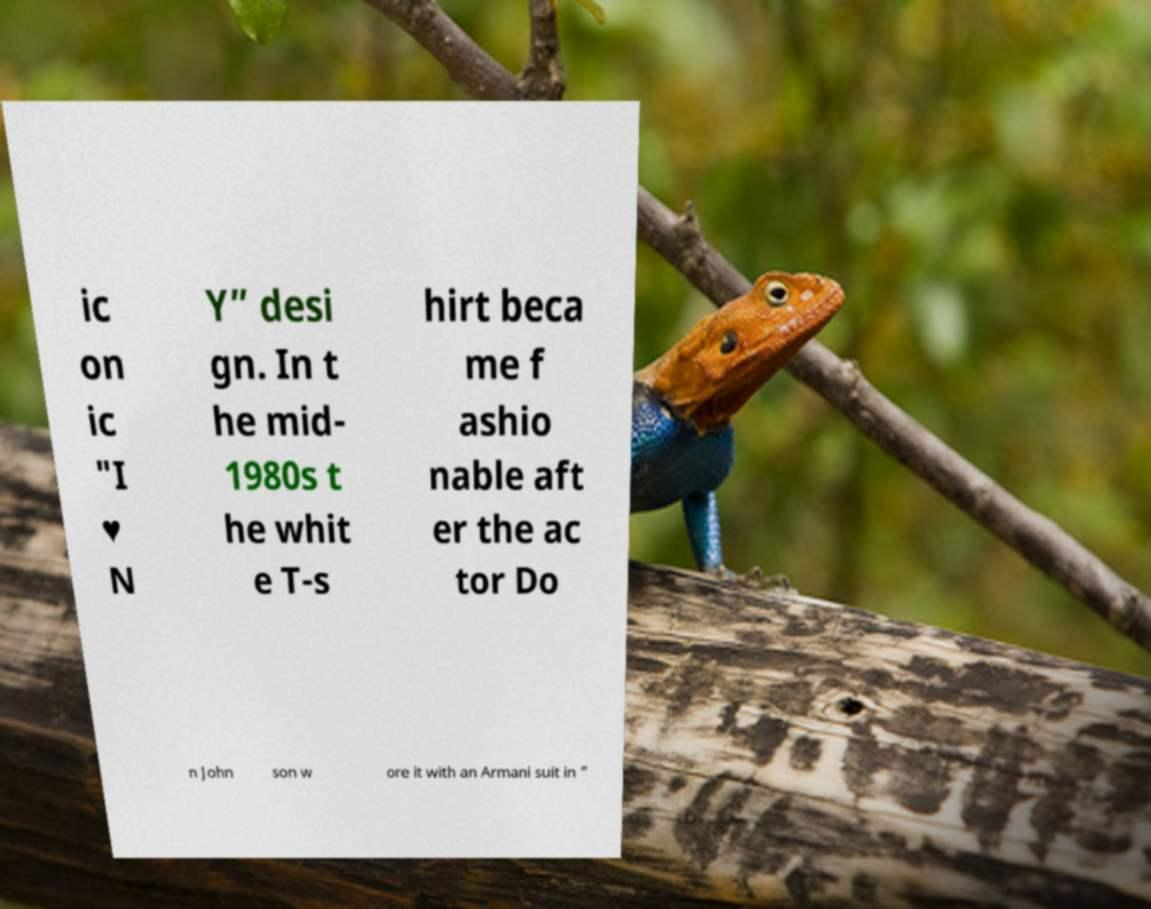Could you extract and type out the text from this image? ic on ic "I ♥ N Y” desi gn. In t he mid- 1980s t he whit e T-s hirt beca me f ashio nable aft er the ac tor Do n John son w ore it with an Armani suit in " 